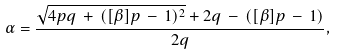<formula> <loc_0><loc_0><loc_500><loc_500>\alpha = \frac { \sqrt { 4 p q \, + \, ( [ \beta ] p \, - \, 1 ) ^ { 2 } } + 2 q \, - \, ( [ \beta ] p \, - \, 1 ) } { 2 q } ,</formula> 